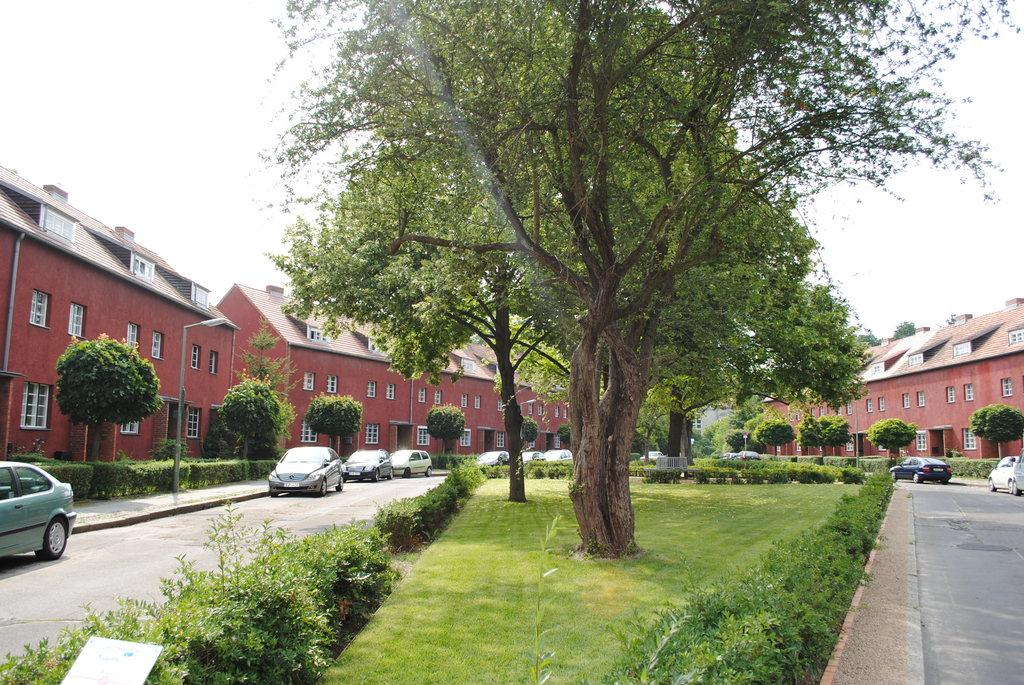What type of structures can be seen in the image? There are buildings in the image. What vehicles are parked in the image? Cars are parked in the image. What type of vegetation is present in the image? Trees and plants are visible in the image. What is on the ground in the image? Grass is on the ground in the image. What type of lighting is present on the sidewalk in the image? There is a pole light on the sidewalk in the image. What is the condition of the sky in the image? The sky is cloudy in the image. How does the brain join the conversation in the image? There is no brain present in the image, and therefore it cannot join the conversation. What point is the image trying to make about the environment? The image does not make a specific point about the environment; it simply depicts a scene with buildings, cars, trees, plants, grass, a pole light, and a cloudy sky. 